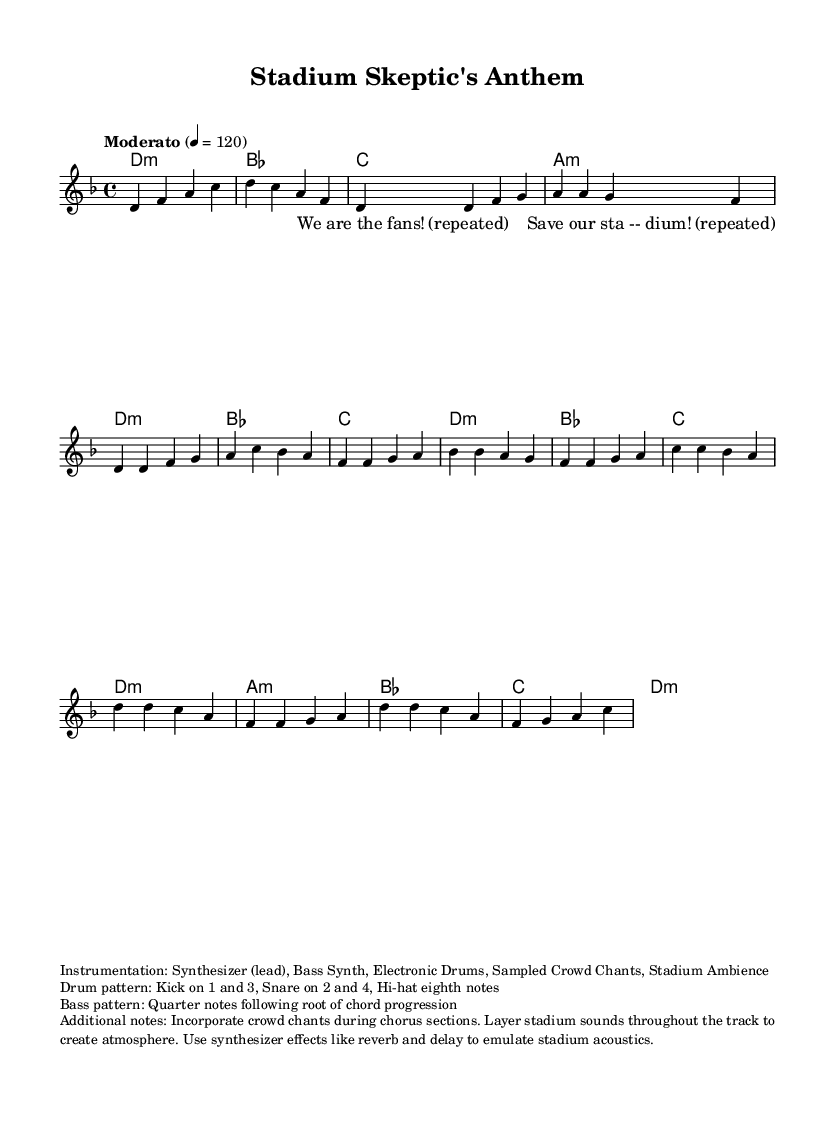What is the key signature of this music? The key signature is indicated at the beginning of the music. It shows one flat (B flat) and corresponds to the key of D minor.
Answer: D minor What is the time signature of this music? The time signature is specified at the start of the score; it indicates that there are four beats per measure, which is represented as 4/4.
Answer: 4/4 What is the tempo marking of the piece? The tempo is indicated as "Moderato" with a metronome marking of 120 beats per minute, suggesting a moderate pace for the piece.
Answer: Moderato 4 = 120 How many measures are in the melody section? By counting the individual groups of music notation (the segments separated by vertical lines), there are 16 measures in the melody section outlined in the music.
Answer: 16 In which section are crowd chants incorporated? The additional notes indicate that the crowd chants are to be incorporated during the chorus sections of the piece.
Answer: Chorus sections What instrument primarily leads in this composition? The score indicates that the lead voice part is played by a synthesizer, according to the instrumentation notes provided.
Answer: Synthesizer What style of sounds is used throughout the track to enhance atmosphere? The score suggests a use of layered stadium sounds throughout the track, creating an atmosphere that resonates with the experience of being in a stadium.
Answer: Stadium sounds 